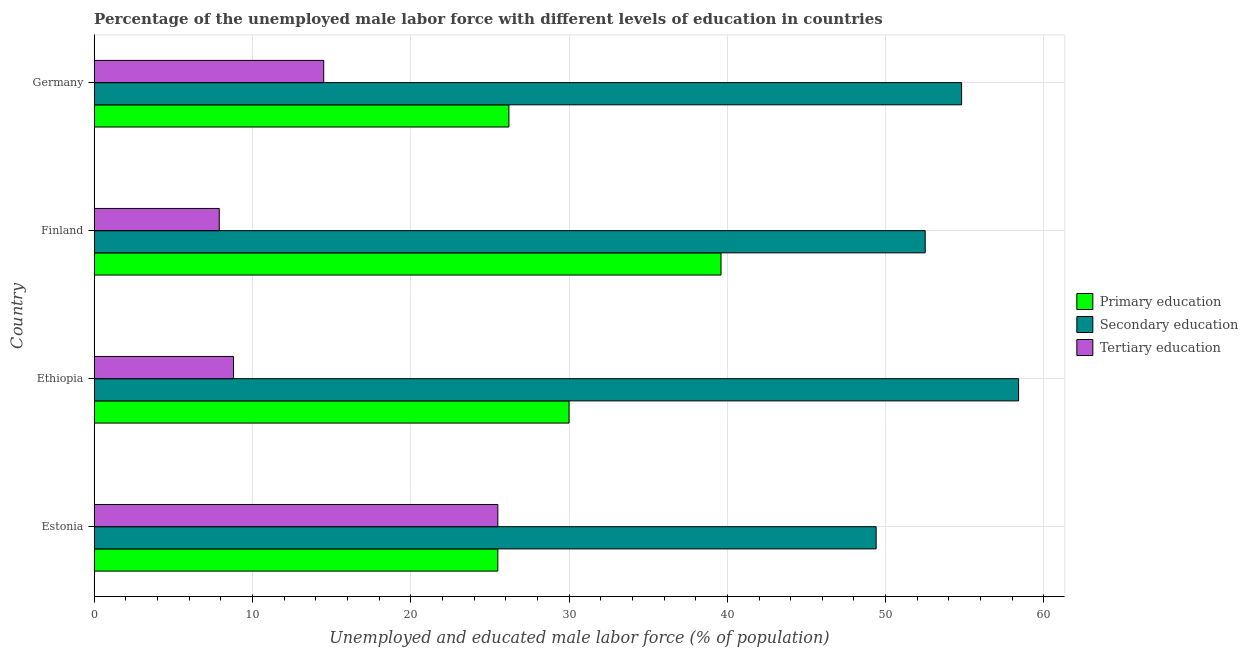How many groups of bars are there?
Offer a very short reply. 4. Are the number of bars on each tick of the Y-axis equal?
Your answer should be compact. Yes. How many bars are there on the 4th tick from the bottom?
Provide a succinct answer. 3. In how many cases, is the number of bars for a given country not equal to the number of legend labels?
Offer a terse response. 0. Across all countries, what is the maximum percentage of male labor force who received primary education?
Give a very brief answer. 39.6. Across all countries, what is the minimum percentage of male labor force who received secondary education?
Keep it short and to the point. 49.4. In which country was the percentage of male labor force who received tertiary education maximum?
Your response must be concise. Estonia. In which country was the percentage of male labor force who received primary education minimum?
Ensure brevity in your answer.  Estonia. What is the total percentage of male labor force who received tertiary education in the graph?
Your answer should be very brief. 56.7. What is the difference between the percentage of male labor force who received secondary education in Ethiopia and that in Germany?
Offer a very short reply. 3.6. What is the difference between the percentage of male labor force who received secondary education in Estonia and the percentage of male labor force who received primary education in Finland?
Provide a short and direct response. 9.8. What is the average percentage of male labor force who received tertiary education per country?
Your answer should be compact. 14.18. What is the difference between the percentage of male labor force who received tertiary education and percentage of male labor force who received primary education in Estonia?
Your answer should be very brief. 0. What is the ratio of the percentage of male labor force who received primary education in Estonia to that in Finland?
Provide a short and direct response. 0.64. Is the percentage of male labor force who received secondary education in Ethiopia less than that in Germany?
Make the answer very short. No. What is the difference between the highest and the lowest percentage of male labor force who received tertiary education?
Provide a succinct answer. 17.6. What does the 1st bar from the top in Germany represents?
Your answer should be very brief. Tertiary education. What does the 2nd bar from the bottom in Ethiopia represents?
Your answer should be very brief. Secondary education. Are all the bars in the graph horizontal?
Provide a succinct answer. Yes. What is the difference between two consecutive major ticks on the X-axis?
Provide a succinct answer. 10. Does the graph contain any zero values?
Offer a very short reply. No. Where does the legend appear in the graph?
Offer a terse response. Center right. How many legend labels are there?
Your answer should be compact. 3. What is the title of the graph?
Your answer should be compact. Percentage of the unemployed male labor force with different levels of education in countries. What is the label or title of the X-axis?
Your response must be concise. Unemployed and educated male labor force (% of population). What is the Unemployed and educated male labor force (% of population) of Secondary education in Estonia?
Ensure brevity in your answer.  49.4. What is the Unemployed and educated male labor force (% of population) of Tertiary education in Estonia?
Your answer should be compact. 25.5. What is the Unemployed and educated male labor force (% of population) of Secondary education in Ethiopia?
Your answer should be very brief. 58.4. What is the Unemployed and educated male labor force (% of population) in Tertiary education in Ethiopia?
Your answer should be very brief. 8.8. What is the Unemployed and educated male labor force (% of population) of Primary education in Finland?
Keep it short and to the point. 39.6. What is the Unemployed and educated male labor force (% of population) of Secondary education in Finland?
Provide a succinct answer. 52.5. What is the Unemployed and educated male labor force (% of population) of Tertiary education in Finland?
Give a very brief answer. 7.9. What is the Unemployed and educated male labor force (% of population) of Primary education in Germany?
Provide a short and direct response. 26.2. What is the Unemployed and educated male labor force (% of population) in Secondary education in Germany?
Make the answer very short. 54.8. What is the Unemployed and educated male labor force (% of population) of Tertiary education in Germany?
Give a very brief answer. 14.5. Across all countries, what is the maximum Unemployed and educated male labor force (% of population) of Primary education?
Keep it short and to the point. 39.6. Across all countries, what is the maximum Unemployed and educated male labor force (% of population) in Secondary education?
Offer a terse response. 58.4. Across all countries, what is the minimum Unemployed and educated male labor force (% of population) in Secondary education?
Your response must be concise. 49.4. Across all countries, what is the minimum Unemployed and educated male labor force (% of population) in Tertiary education?
Your answer should be compact. 7.9. What is the total Unemployed and educated male labor force (% of population) of Primary education in the graph?
Your response must be concise. 121.3. What is the total Unemployed and educated male labor force (% of population) of Secondary education in the graph?
Your response must be concise. 215.1. What is the total Unemployed and educated male labor force (% of population) in Tertiary education in the graph?
Your answer should be compact. 56.7. What is the difference between the Unemployed and educated male labor force (% of population) of Primary education in Estonia and that in Ethiopia?
Your answer should be compact. -4.5. What is the difference between the Unemployed and educated male labor force (% of population) in Secondary education in Estonia and that in Ethiopia?
Provide a short and direct response. -9. What is the difference between the Unemployed and educated male labor force (% of population) of Tertiary education in Estonia and that in Ethiopia?
Ensure brevity in your answer.  16.7. What is the difference between the Unemployed and educated male labor force (% of population) in Primary education in Estonia and that in Finland?
Make the answer very short. -14.1. What is the difference between the Unemployed and educated male labor force (% of population) in Tertiary education in Estonia and that in Finland?
Provide a short and direct response. 17.6. What is the difference between the Unemployed and educated male labor force (% of population) in Primary education in Estonia and that in Germany?
Give a very brief answer. -0.7. What is the difference between the Unemployed and educated male labor force (% of population) in Tertiary education in Estonia and that in Germany?
Provide a succinct answer. 11. What is the difference between the Unemployed and educated male labor force (% of population) of Secondary education in Finland and that in Germany?
Provide a short and direct response. -2.3. What is the difference between the Unemployed and educated male labor force (% of population) in Tertiary education in Finland and that in Germany?
Your response must be concise. -6.6. What is the difference between the Unemployed and educated male labor force (% of population) in Primary education in Estonia and the Unemployed and educated male labor force (% of population) in Secondary education in Ethiopia?
Provide a succinct answer. -32.9. What is the difference between the Unemployed and educated male labor force (% of population) of Secondary education in Estonia and the Unemployed and educated male labor force (% of population) of Tertiary education in Ethiopia?
Your response must be concise. 40.6. What is the difference between the Unemployed and educated male labor force (% of population) in Primary education in Estonia and the Unemployed and educated male labor force (% of population) in Secondary education in Finland?
Ensure brevity in your answer.  -27. What is the difference between the Unemployed and educated male labor force (% of population) of Secondary education in Estonia and the Unemployed and educated male labor force (% of population) of Tertiary education in Finland?
Your response must be concise. 41.5. What is the difference between the Unemployed and educated male labor force (% of population) of Primary education in Estonia and the Unemployed and educated male labor force (% of population) of Secondary education in Germany?
Give a very brief answer. -29.3. What is the difference between the Unemployed and educated male labor force (% of population) in Secondary education in Estonia and the Unemployed and educated male labor force (% of population) in Tertiary education in Germany?
Make the answer very short. 34.9. What is the difference between the Unemployed and educated male labor force (% of population) of Primary education in Ethiopia and the Unemployed and educated male labor force (% of population) of Secondary education in Finland?
Give a very brief answer. -22.5. What is the difference between the Unemployed and educated male labor force (% of population) of Primary education in Ethiopia and the Unemployed and educated male labor force (% of population) of Tertiary education in Finland?
Your answer should be very brief. 22.1. What is the difference between the Unemployed and educated male labor force (% of population) in Secondary education in Ethiopia and the Unemployed and educated male labor force (% of population) in Tertiary education in Finland?
Your answer should be very brief. 50.5. What is the difference between the Unemployed and educated male labor force (% of population) in Primary education in Ethiopia and the Unemployed and educated male labor force (% of population) in Secondary education in Germany?
Keep it short and to the point. -24.8. What is the difference between the Unemployed and educated male labor force (% of population) in Secondary education in Ethiopia and the Unemployed and educated male labor force (% of population) in Tertiary education in Germany?
Offer a very short reply. 43.9. What is the difference between the Unemployed and educated male labor force (% of population) of Primary education in Finland and the Unemployed and educated male labor force (% of population) of Secondary education in Germany?
Provide a succinct answer. -15.2. What is the difference between the Unemployed and educated male labor force (% of population) in Primary education in Finland and the Unemployed and educated male labor force (% of population) in Tertiary education in Germany?
Provide a succinct answer. 25.1. What is the difference between the Unemployed and educated male labor force (% of population) of Secondary education in Finland and the Unemployed and educated male labor force (% of population) of Tertiary education in Germany?
Your answer should be very brief. 38. What is the average Unemployed and educated male labor force (% of population) of Primary education per country?
Provide a succinct answer. 30.32. What is the average Unemployed and educated male labor force (% of population) in Secondary education per country?
Ensure brevity in your answer.  53.77. What is the average Unemployed and educated male labor force (% of population) of Tertiary education per country?
Give a very brief answer. 14.18. What is the difference between the Unemployed and educated male labor force (% of population) in Primary education and Unemployed and educated male labor force (% of population) in Secondary education in Estonia?
Your response must be concise. -23.9. What is the difference between the Unemployed and educated male labor force (% of population) of Secondary education and Unemployed and educated male labor force (% of population) of Tertiary education in Estonia?
Your answer should be compact. 23.9. What is the difference between the Unemployed and educated male labor force (% of population) of Primary education and Unemployed and educated male labor force (% of population) of Secondary education in Ethiopia?
Ensure brevity in your answer.  -28.4. What is the difference between the Unemployed and educated male labor force (% of population) in Primary education and Unemployed and educated male labor force (% of population) in Tertiary education in Ethiopia?
Ensure brevity in your answer.  21.2. What is the difference between the Unemployed and educated male labor force (% of population) of Secondary education and Unemployed and educated male labor force (% of population) of Tertiary education in Ethiopia?
Offer a very short reply. 49.6. What is the difference between the Unemployed and educated male labor force (% of population) in Primary education and Unemployed and educated male labor force (% of population) in Tertiary education in Finland?
Offer a terse response. 31.7. What is the difference between the Unemployed and educated male labor force (% of population) of Secondary education and Unemployed and educated male labor force (% of population) of Tertiary education in Finland?
Offer a terse response. 44.6. What is the difference between the Unemployed and educated male labor force (% of population) in Primary education and Unemployed and educated male labor force (% of population) in Secondary education in Germany?
Your answer should be very brief. -28.6. What is the difference between the Unemployed and educated male labor force (% of population) of Primary education and Unemployed and educated male labor force (% of population) of Tertiary education in Germany?
Your answer should be compact. 11.7. What is the difference between the Unemployed and educated male labor force (% of population) in Secondary education and Unemployed and educated male labor force (% of population) in Tertiary education in Germany?
Your answer should be very brief. 40.3. What is the ratio of the Unemployed and educated male labor force (% of population) of Secondary education in Estonia to that in Ethiopia?
Give a very brief answer. 0.85. What is the ratio of the Unemployed and educated male labor force (% of population) in Tertiary education in Estonia to that in Ethiopia?
Ensure brevity in your answer.  2.9. What is the ratio of the Unemployed and educated male labor force (% of population) in Primary education in Estonia to that in Finland?
Offer a very short reply. 0.64. What is the ratio of the Unemployed and educated male labor force (% of population) of Secondary education in Estonia to that in Finland?
Make the answer very short. 0.94. What is the ratio of the Unemployed and educated male labor force (% of population) of Tertiary education in Estonia to that in Finland?
Keep it short and to the point. 3.23. What is the ratio of the Unemployed and educated male labor force (% of population) of Primary education in Estonia to that in Germany?
Your answer should be very brief. 0.97. What is the ratio of the Unemployed and educated male labor force (% of population) of Secondary education in Estonia to that in Germany?
Provide a short and direct response. 0.9. What is the ratio of the Unemployed and educated male labor force (% of population) in Tertiary education in Estonia to that in Germany?
Provide a succinct answer. 1.76. What is the ratio of the Unemployed and educated male labor force (% of population) in Primary education in Ethiopia to that in Finland?
Ensure brevity in your answer.  0.76. What is the ratio of the Unemployed and educated male labor force (% of population) in Secondary education in Ethiopia to that in Finland?
Offer a very short reply. 1.11. What is the ratio of the Unemployed and educated male labor force (% of population) in Tertiary education in Ethiopia to that in Finland?
Provide a short and direct response. 1.11. What is the ratio of the Unemployed and educated male labor force (% of population) of Primary education in Ethiopia to that in Germany?
Provide a short and direct response. 1.15. What is the ratio of the Unemployed and educated male labor force (% of population) in Secondary education in Ethiopia to that in Germany?
Provide a short and direct response. 1.07. What is the ratio of the Unemployed and educated male labor force (% of population) in Tertiary education in Ethiopia to that in Germany?
Offer a terse response. 0.61. What is the ratio of the Unemployed and educated male labor force (% of population) of Primary education in Finland to that in Germany?
Keep it short and to the point. 1.51. What is the ratio of the Unemployed and educated male labor force (% of population) in Secondary education in Finland to that in Germany?
Give a very brief answer. 0.96. What is the ratio of the Unemployed and educated male labor force (% of population) in Tertiary education in Finland to that in Germany?
Make the answer very short. 0.54. What is the difference between the highest and the second highest Unemployed and educated male labor force (% of population) of Primary education?
Provide a short and direct response. 9.6. What is the difference between the highest and the lowest Unemployed and educated male labor force (% of population) in Primary education?
Provide a short and direct response. 14.1. What is the difference between the highest and the lowest Unemployed and educated male labor force (% of population) of Tertiary education?
Give a very brief answer. 17.6. 